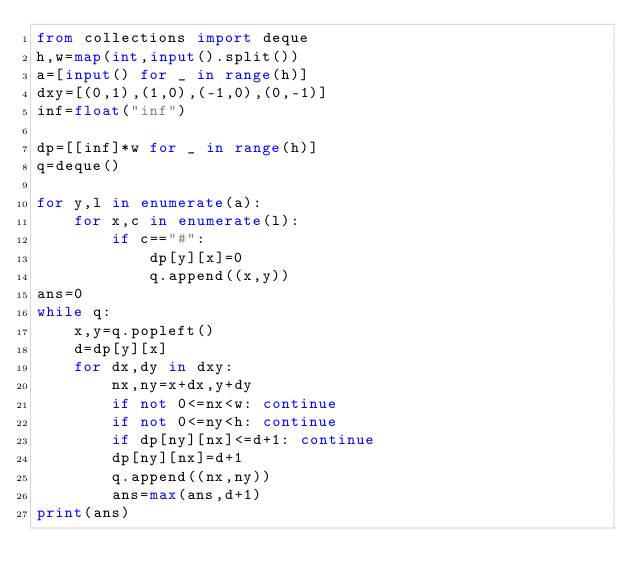Convert code to text. <code><loc_0><loc_0><loc_500><loc_500><_Python_>from collections import deque
h,w=map(int,input().split())
a=[input() for _ in range(h)]
dxy=[(0,1),(1,0),(-1,0),(0,-1)]
inf=float("inf")

dp=[[inf]*w for _ in range(h)]
q=deque()

for y,l in enumerate(a):
    for x,c in enumerate(l):
        if c=="#":
            dp[y][x]=0
            q.append((x,y))
ans=0
while q:
    x,y=q.popleft()
    d=dp[y][x]
    for dx,dy in dxy:
        nx,ny=x+dx,y+dy
        if not 0<=nx<w: continue
        if not 0<=ny<h: continue
        if dp[ny][nx]<=d+1: continue
        dp[ny][nx]=d+1
        q.append((nx,ny))
        ans=max(ans,d+1)
print(ans)
</code> 